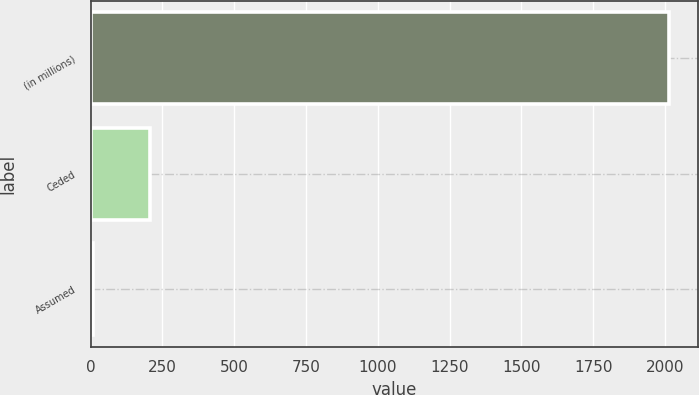<chart> <loc_0><loc_0><loc_500><loc_500><bar_chart><fcel>(in millions)<fcel>Ceded<fcel>Assumed<nl><fcel>2013<fcel>207.6<fcel>7<nl></chart> 